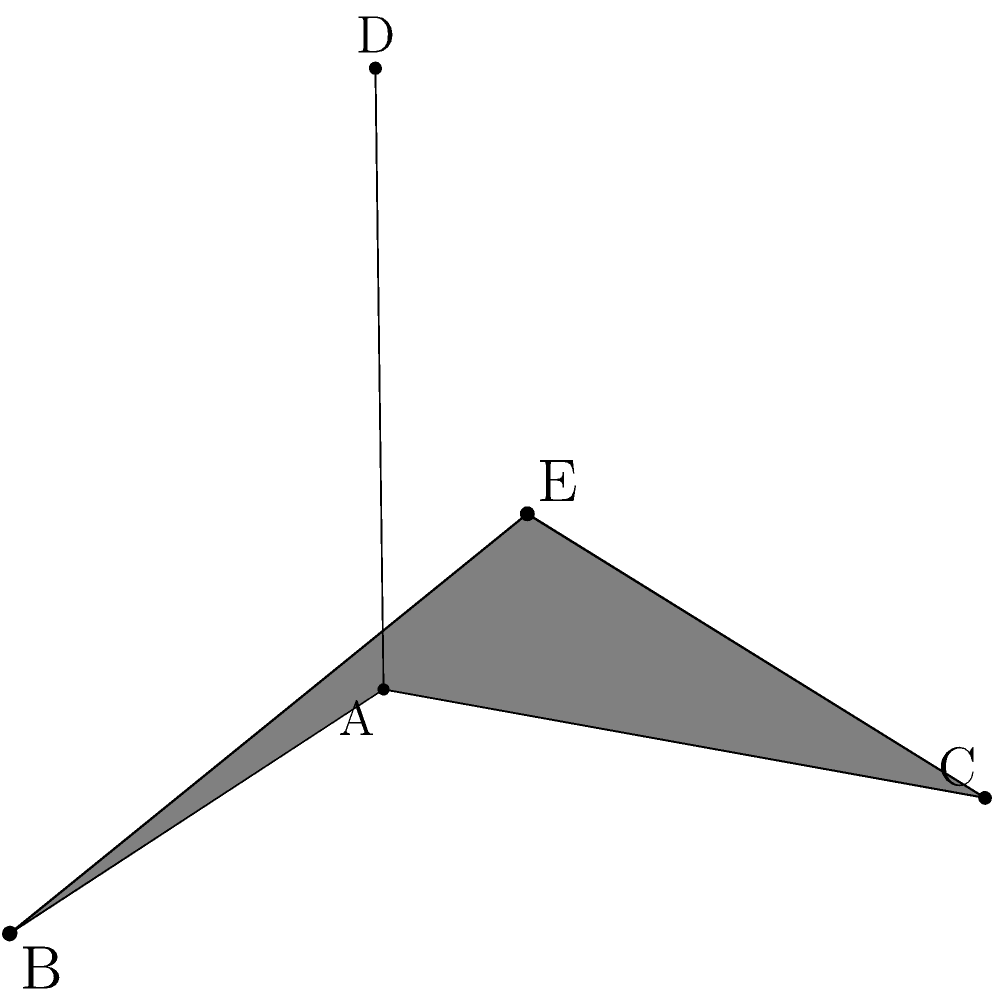In your ceramic sculpture, two planes intersect as shown in the diagram. Plane ABC is represented in blue, and plane ACD is represented in red. Given that $\vec{AB} = (2,0,0)$, $\vec{AC} = (0,2,0)$, and $\vec{AD} = (0,0,2)$, determine the angle between these two planes. To find the angle between two planes, we need to follow these steps:

1) First, we need to find the normal vectors of both planes:
   
   For plane ABC: $\vec{n_1} = \vec{AB} \times \vec{AC} = (2,0,0) \times (0,2,0) = (0,0,4)$
   For plane ACD: $\vec{n_2} = \vec{AC} \times \vec{AD} = (0,2,0) \times (0,0,2) = (4,0,0)$

2) The angle between the planes is the same as the angle between their normal vectors. We can find this using the dot product formula:

   $\cos \theta = \frac{\vec{n_1} \cdot \vec{n_2}}{|\vec{n_1}||\vec{n_2}|}$

3) Calculate the dot product:
   $\vec{n_1} \cdot \vec{n_2} = (0,0,4) \cdot (4,0,0) = 0$

4) Calculate the magnitudes:
   $|\vec{n_1}| = \sqrt{0^2 + 0^2 + 4^2} = 4$
   $|\vec{n_2}| = \sqrt{4^2 + 0^2 + 0^2} = 4$

5) Substitute into the formula:
   $\cos \theta = \frac{0}{4 \cdot 4} = 0$

6) Solve for $\theta$:
   $\theta = \arccos(0) = 90°$

Therefore, the angle between the two planes is 90°.
Answer: 90° 